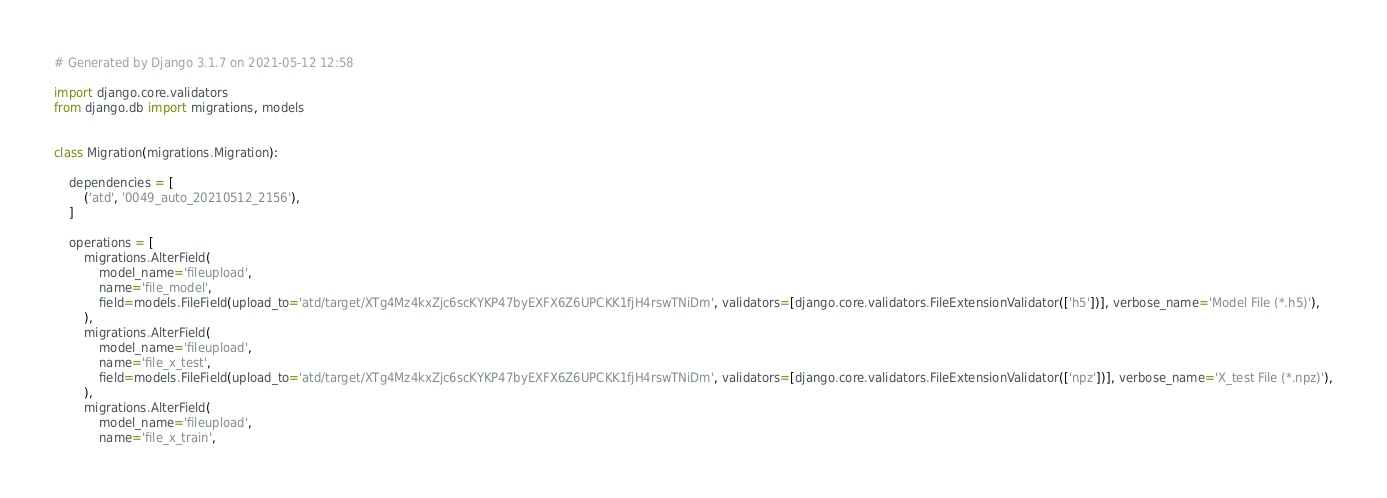Convert code to text. <code><loc_0><loc_0><loc_500><loc_500><_Python_># Generated by Django 3.1.7 on 2021-05-12 12:58

import django.core.validators
from django.db import migrations, models


class Migration(migrations.Migration):

    dependencies = [
        ('atd', '0049_auto_20210512_2156'),
    ]

    operations = [
        migrations.AlterField(
            model_name='fileupload',
            name='file_model',
            field=models.FileField(upload_to='atd/target/XTg4Mz4kxZjc6scKYKP47byEXFX6Z6UPCKK1fjH4rswTNiDm', validators=[django.core.validators.FileExtensionValidator(['h5'])], verbose_name='Model File (*.h5)'),
        ),
        migrations.AlterField(
            model_name='fileupload',
            name='file_x_test',
            field=models.FileField(upload_to='atd/target/XTg4Mz4kxZjc6scKYKP47byEXFX6Z6UPCKK1fjH4rswTNiDm', validators=[django.core.validators.FileExtensionValidator(['npz'])], verbose_name='X_test File (*.npz)'),
        ),
        migrations.AlterField(
            model_name='fileupload',
            name='file_x_train',</code> 